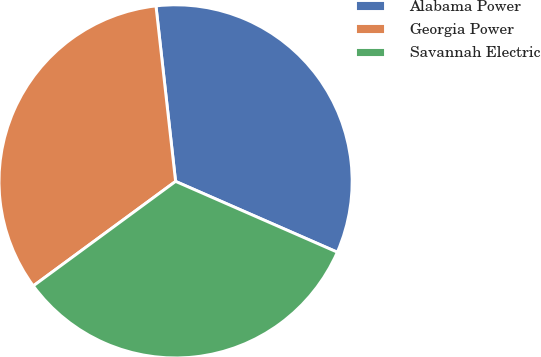Convert chart to OTSL. <chart><loc_0><loc_0><loc_500><loc_500><pie_chart><fcel>Alabama Power<fcel>Georgia Power<fcel>Savannah Electric<nl><fcel>33.34%<fcel>33.31%<fcel>33.35%<nl></chart> 